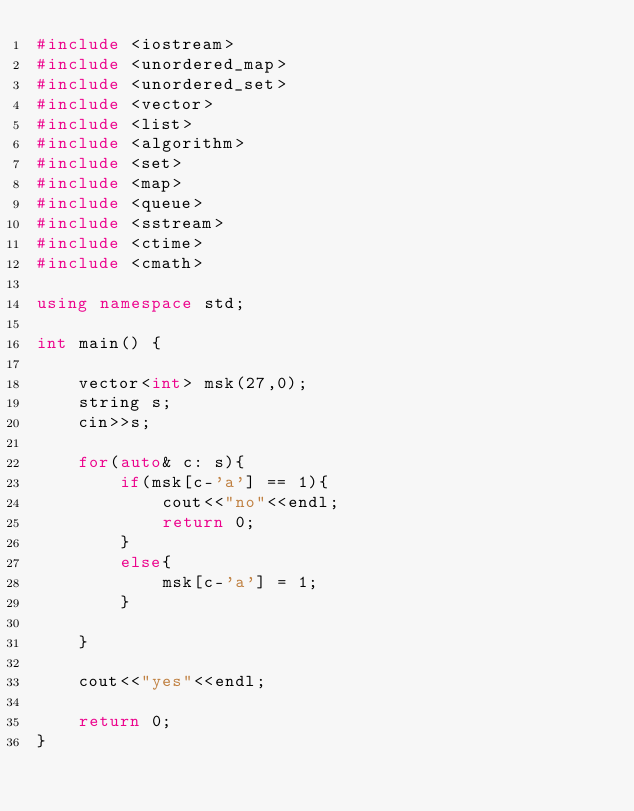Convert code to text. <code><loc_0><loc_0><loc_500><loc_500><_C++_>#include <iostream>
#include <unordered_map>
#include <unordered_set>
#include <vector>
#include <list>
#include <algorithm>
#include <set>
#include <map>
#include <queue>
#include <sstream>
#include <ctime>
#include <cmath>

using namespace std;

int main() {

    vector<int> msk(27,0);
    string s;
    cin>>s;

    for(auto& c: s){
        if(msk[c-'a'] == 1){
            cout<<"no"<<endl;
            return 0;
        }
        else{
            msk[c-'a'] = 1;
        }

    }

    cout<<"yes"<<endl;

    return 0;
}</code> 